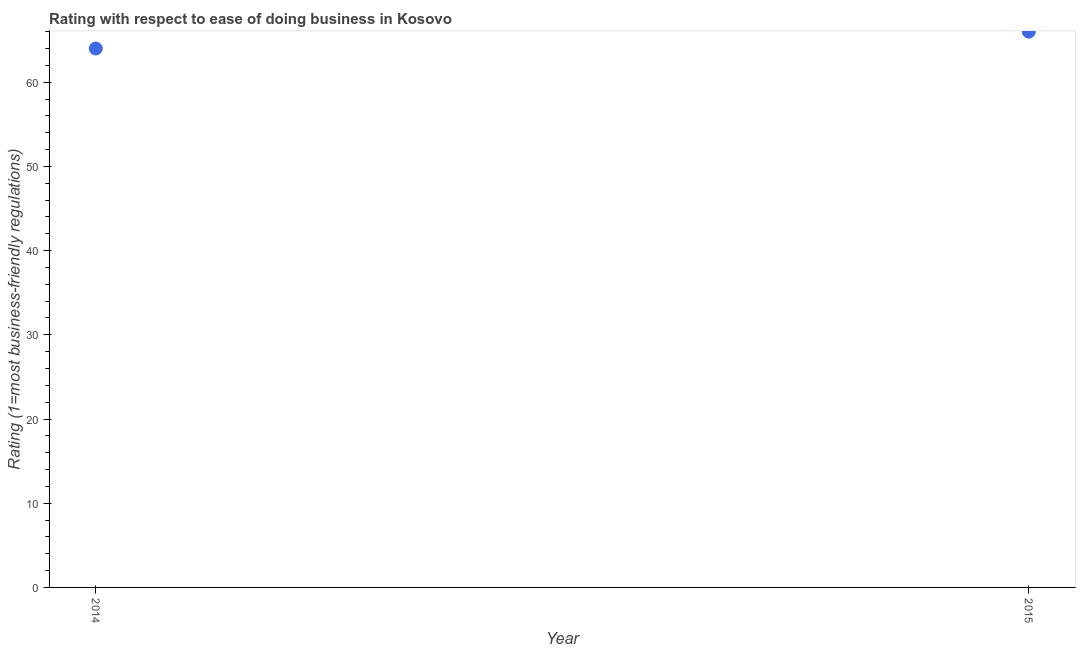What is the ease of doing business index in 2014?
Make the answer very short. 64. Across all years, what is the maximum ease of doing business index?
Offer a very short reply. 66. Across all years, what is the minimum ease of doing business index?
Your answer should be very brief. 64. In which year was the ease of doing business index maximum?
Your answer should be compact. 2015. What is the sum of the ease of doing business index?
Give a very brief answer. 130. What is the difference between the ease of doing business index in 2014 and 2015?
Provide a succinct answer. -2. What is the median ease of doing business index?
Your answer should be compact. 65. Do a majority of the years between 2015 and 2014 (inclusive) have ease of doing business index greater than 38 ?
Make the answer very short. No. What is the ratio of the ease of doing business index in 2014 to that in 2015?
Your response must be concise. 0.97. Is the ease of doing business index in 2014 less than that in 2015?
Give a very brief answer. Yes. In how many years, is the ease of doing business index greater than the average ease of doing business index taken over all years?
Make the answer very short. 1. Does the ease of doing business index monotonically increase over the years?
Ensure brevity in your answer.  Yes. How many dotlines are there?
Provide a short and direct response. 1. How many years are there in the graph?
Offer a very short reply. 2. What is the difference between two consecutive major ticks on the Y-axis?
Your response must be concise. 10. Are the values on the major ticks of Y-axis written in scientific E-notation?
Keep it short and to the point. No. What is the title of the graph?
Your response must be concise. Rating with respect to ease of doing business in Kosovo. What is the label or title of the Y-axis?
Your answer should be very brief. Rating (1=most business-friendly regulations). What is the difference between the Rating (1=most business-friendly regulations) in 2014 and 2015?
Offer a very short reply. -2. 